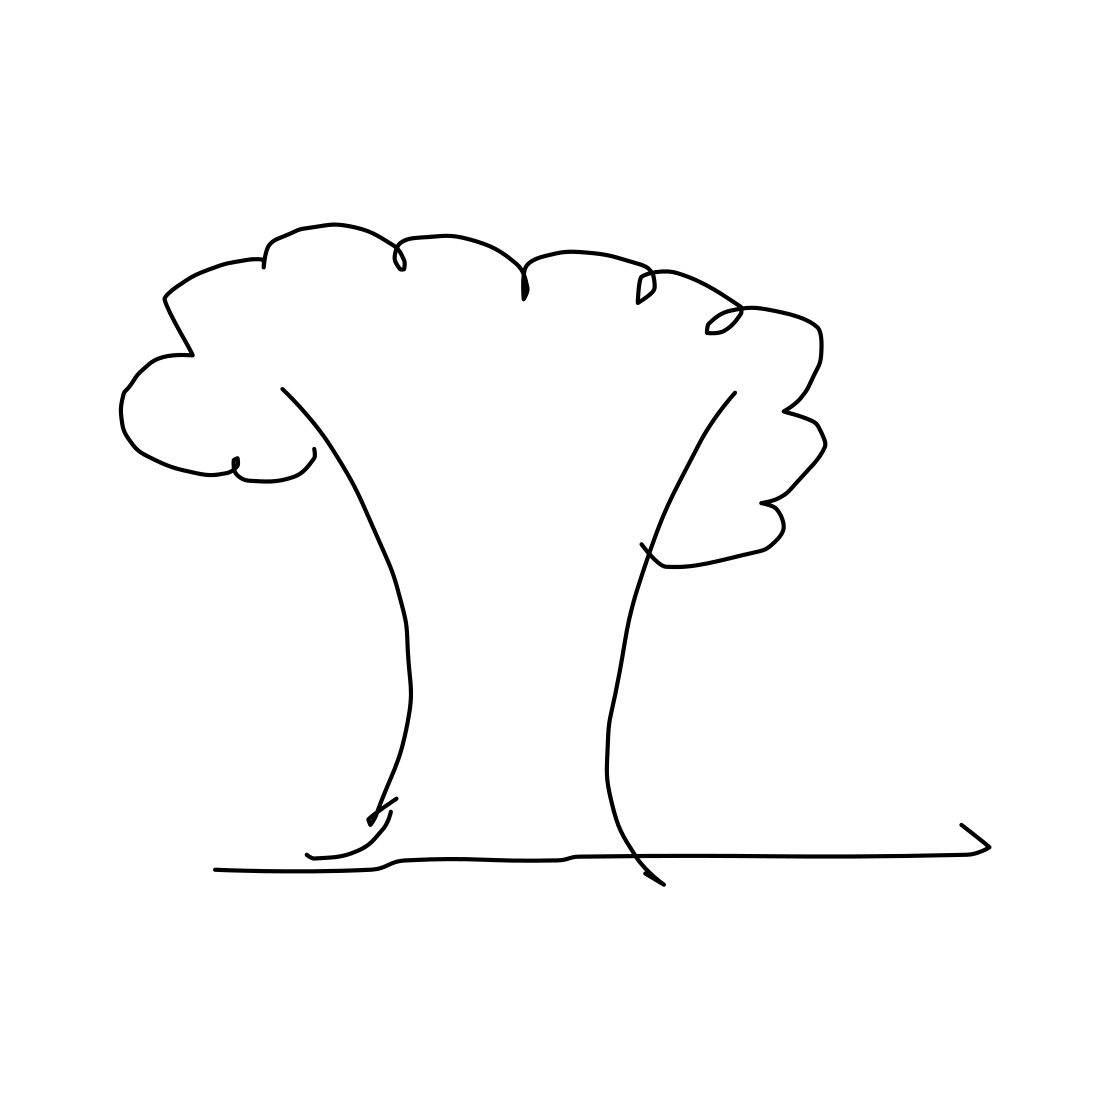What is the mood conveyed by this picture of a tree? The simplicity and clarity of the lines may evoke a sense of calm and straightforwardness. The absence of detail can be interpreted as freeing or could represent the essence of a tree stripped down to its most basic form. 